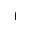<formula> <loc_0><loc_0><loc_500><loc_500>+</formula> 